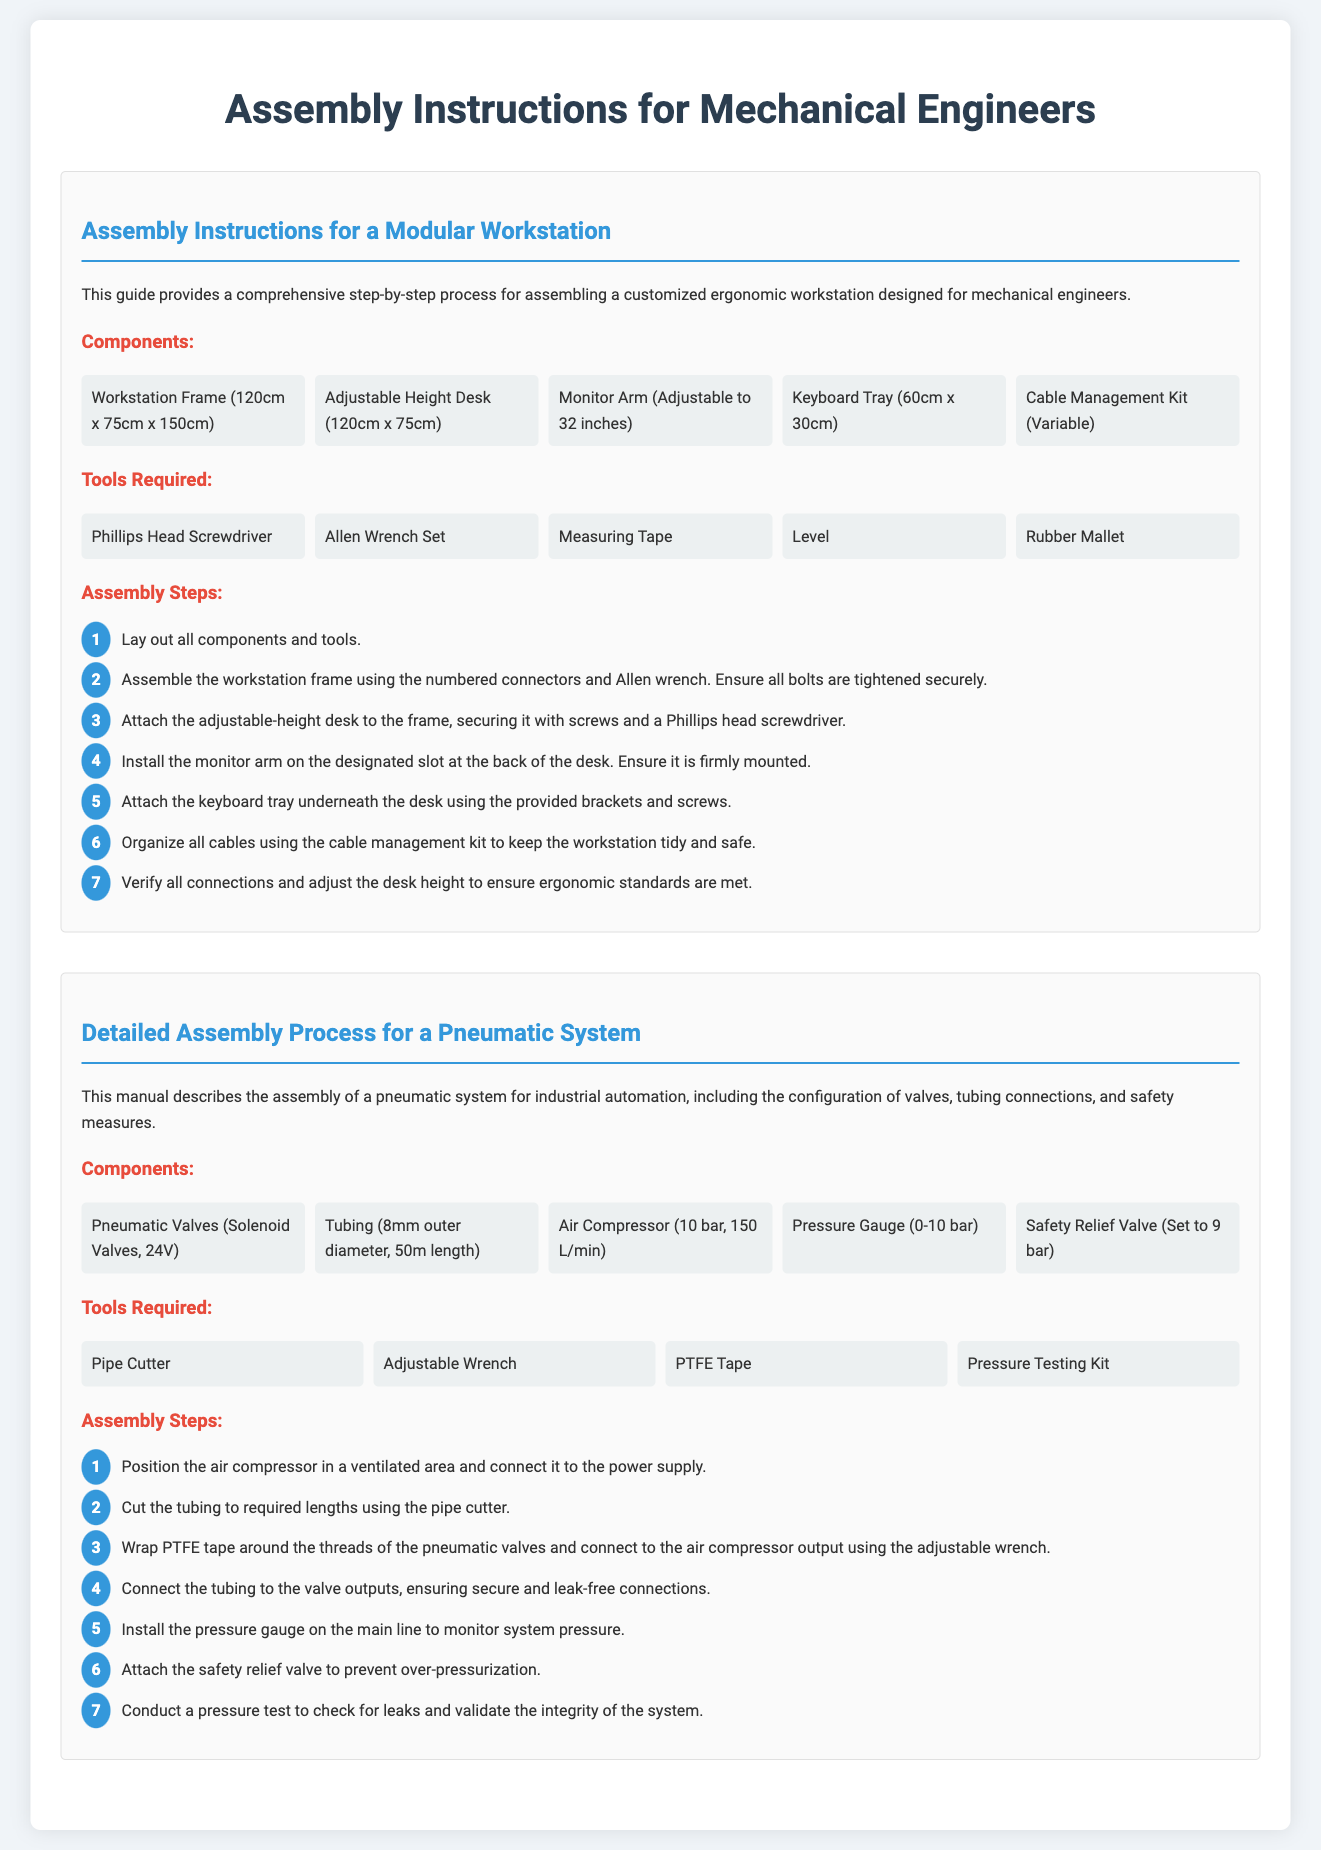What is the size of the workstation frame? The dimension of the workstation frame is specified in the document as 120cm x 75cm x 150cm.
Answer: 120cm x 75cm x 150cm How many pneumatic valves are included? The number of pneumatic valves is mentioned in the components section as "Solenoid Valves, 24V", suggesting there are multiple but not specified.
Answer: Multiple What tool is needed to connect the tubing? The document states that a pipe cutter is necessary for cutting the tubing to required lengths.
Answer: Pipe Cutter What is the maximum pressure setting for the safety relief valve? The safety relief valve is set to prevent over-pressurization, with a specification of 9 bar stated in the document.
Answer: 9 bar How many assembly steps are there for the modular workstation? The document lists seven distinct assembly steps specifically for the modular workstation assembly.
Answer: Seven What length of tubing is required for the pneumatic system? The assembly instructions specify the required tubing length as 50m for the pneumatic system.
Answer: 50m Which tool is used for testing pressure in the pneumatic system? The document identifies a pressure testing kit as the tool used for conducting pressure tests in the pneumatic system assembly.
Answer: Pressure Testing Kit What feature does the adjustable height desk provide? The document describes the adjustable height desk as a component that allows for customization in height, ensuring ergonomic use.
Answer: Adjustable Height How is cable organization addressed in the modular workstation? A cable management kit is included in the components to organize and maintain a tidy setup in the modular workstation.
Answer: Cable Management Kit 